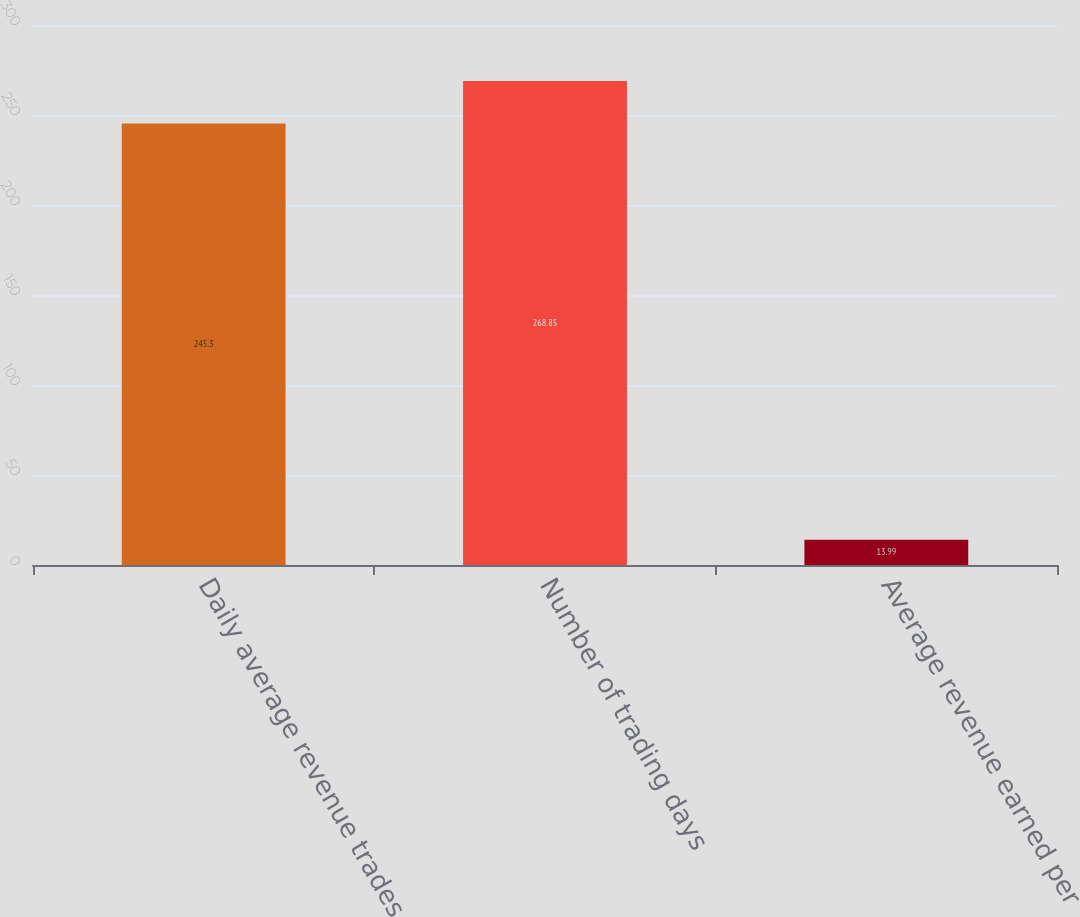Convert chart. <chart><loc_0><loc_0><loc_500><loc_500><bar_chart><fcel>Daily average revenue trades<fcel>Number of trading days<fcel>Average revenue earned per<nl><fcel>245.3<fcel>268.85<fcel>13.99<nl></chart> 